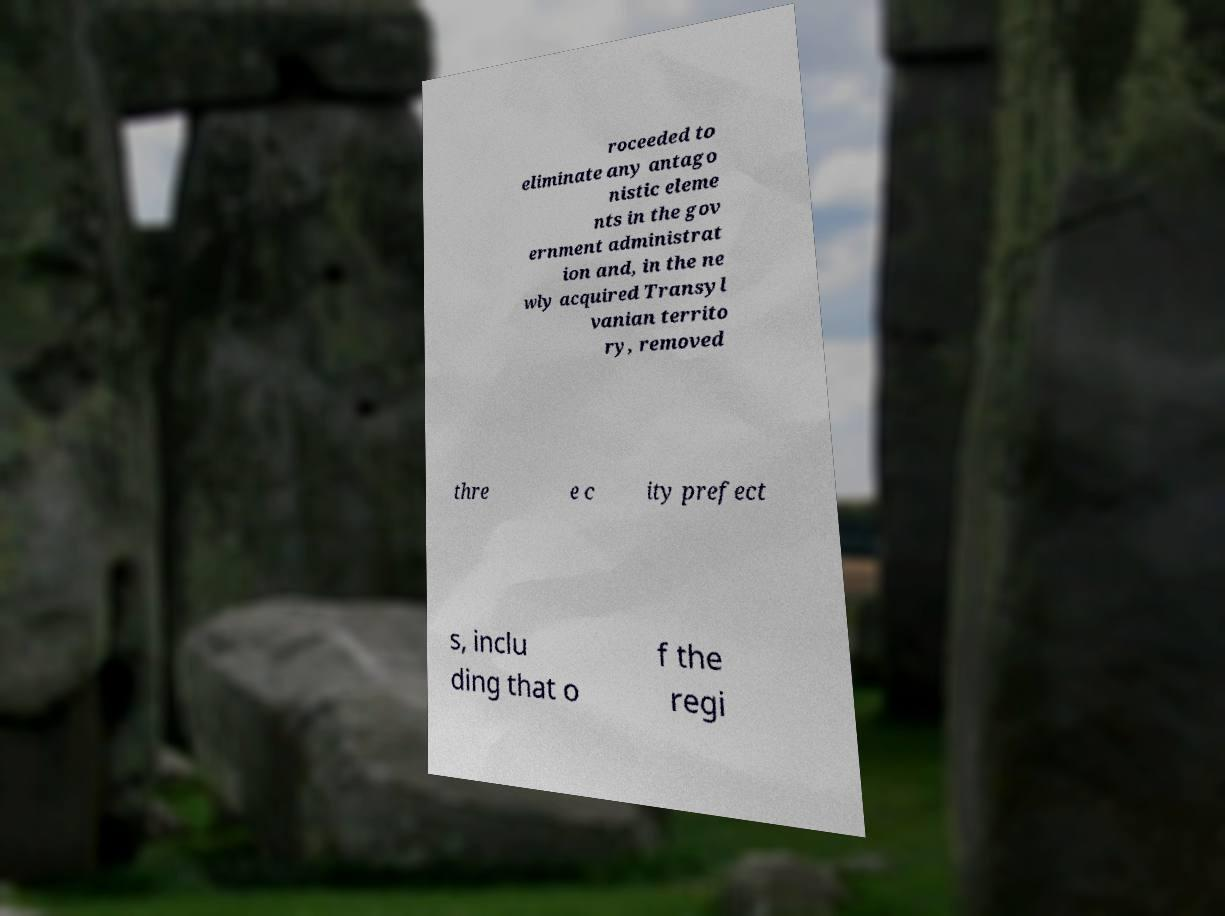Could you assist in decoding the text presented in this image and type it out clearly? roceeded to eliminate any antago nistic eleme nts in the gov ernment administrat ion and, in the ne wly acquired Transyl vanian territo ry, removed thre e c ity prefect s, inclu ding that o f the regi 